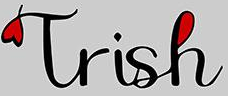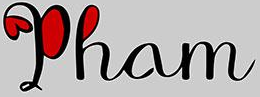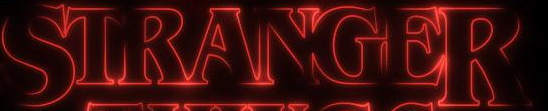What text is displayed in these images sequentially, separated by a semicolon? Trish; Pham; STRANGER 